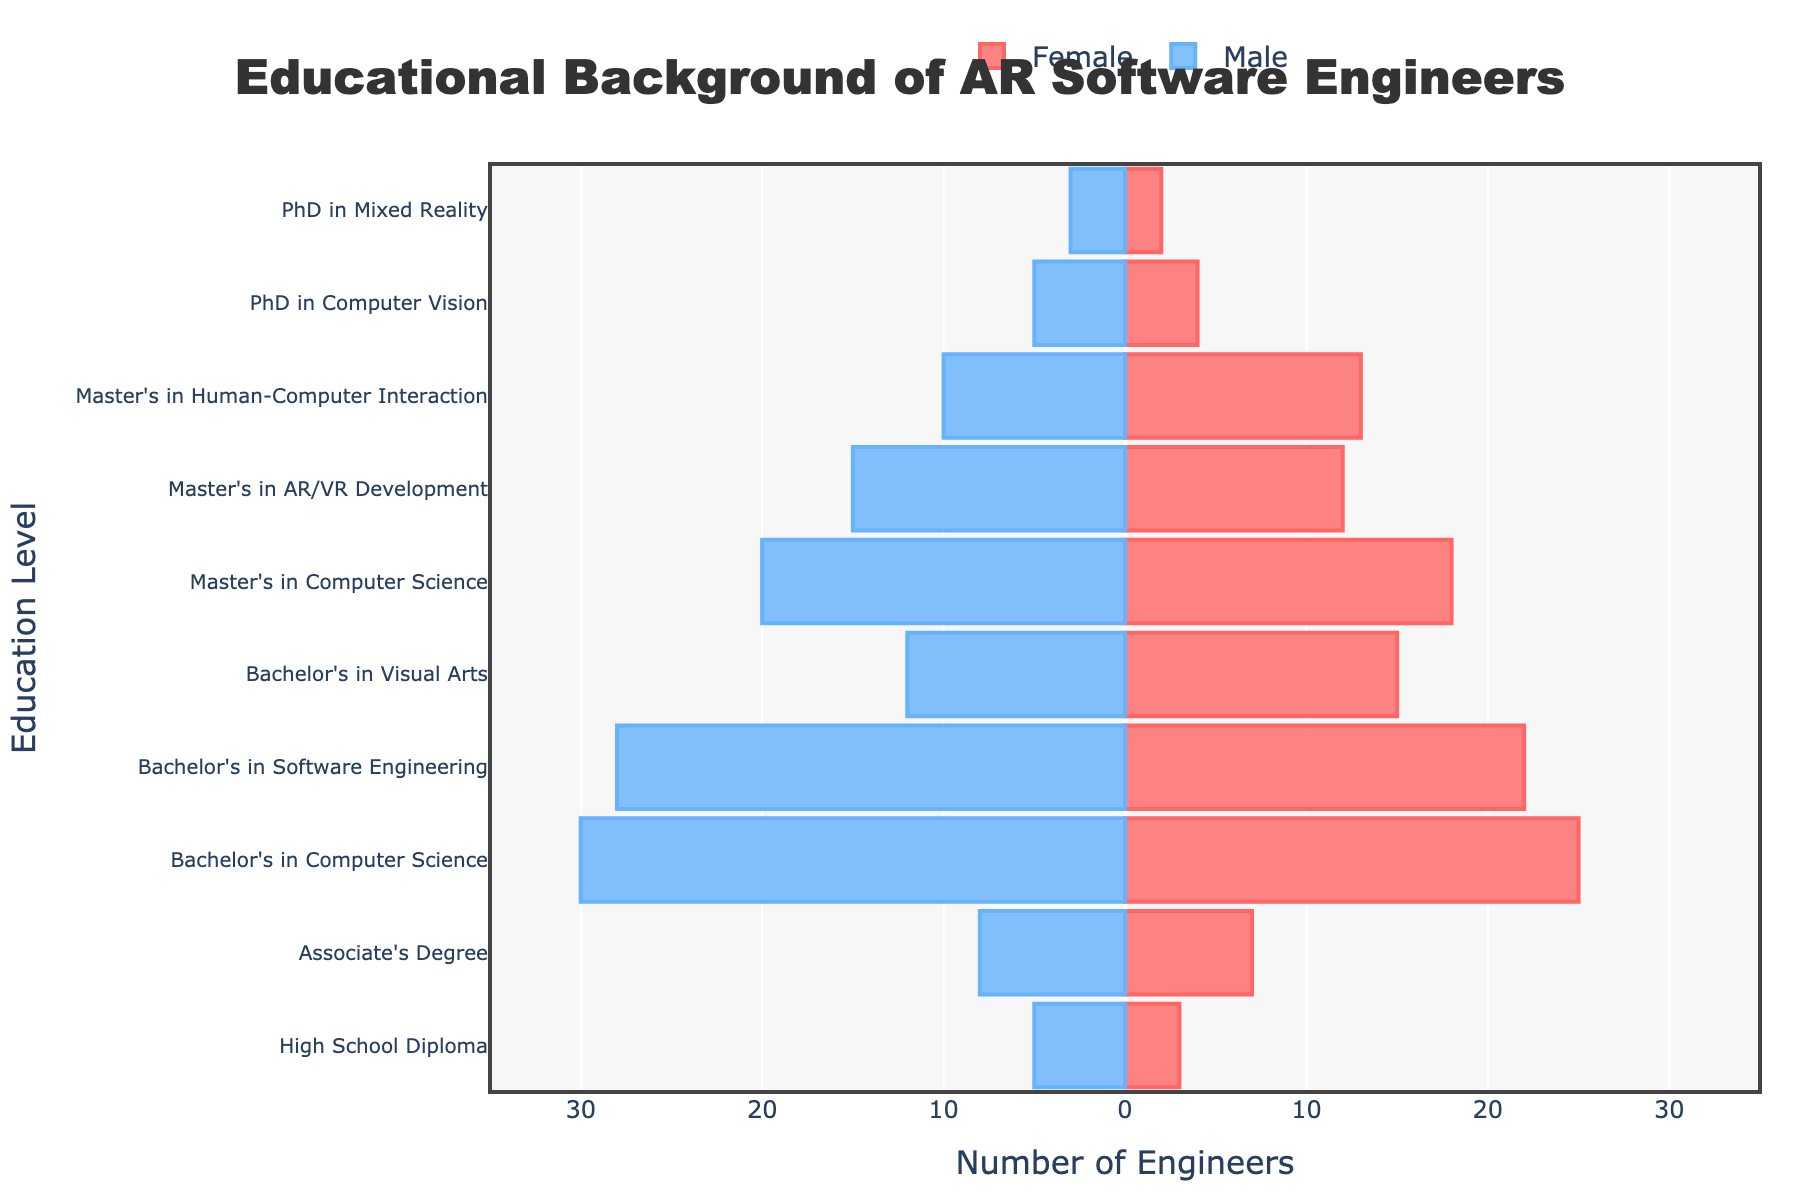who has the highest number among males with a Bachelor's degree? To find the highest number among males with a Bachelor's degree, look at the bars for "Bachelor's in Computer Science," "Bachelor's in Software Engineering," and "Bachelor's in Visual Arts." The male counts are 30, 28, and 12, respectively. So, the highest number is 30 for "Bachelor's in Computer Science."
Answer: Bachelor's in Computer Science What is the total number of engineers with a Master's in AR/VR Development? Sum the male and female counts for "Master's in AR/VR Development." The male count is 15 and the female count is 12. 15 + 12 = 27.
Answer: 27 Which education level has more female engineers compared to male engineers? Compare the female and male counts at each education level: "Bachelor's in Visual Arts" has 15 females and 12 males, meaning it has more female engineers.
Answer: Bachelor's in Visual Arts What is the difference in the number of male and female engineers with a Master's in Human-Computer Interaction? Subtract the female count from the male count for "Master's in Human-Computer Interaction." The male count is 10 and the female count is 13. 10 - 13 = -3.
Answer: -3 Which education level has the smallest gender difference? Compare the differences between male and female counts at each education level. "PhD in Mixed Reality" has a difference of 1 (3 males vs 2 females), which is the smallest.
Answer: PhD in Mixed Reality How many engineers in total have a High School Diploma? Sum the male and female counts for "High School Diploma." The male count is 5 and the female count is 3. 5 + 3 = 8.
Answer: 8 What is the total number of engineers with a Ph.D. across all fields? Sum the counts for all Ph.D. fields: "PhD in Computer Vision" has 5 males and 4 females (5 + 4 = 9), and "PhD in Mixed Reality" has 3 males and 2 females (3 + 2 = 5). 9 + 5 = 14.
Answer: 14 Which education level has the highest total number of engineers? Add the male and female counts for each education level and compare. "Bachelor's in Computer Science" has the highest total with 30 males and 25 females. 30 + 25 = 55.
Answer: Bachelor's in Computer Science 